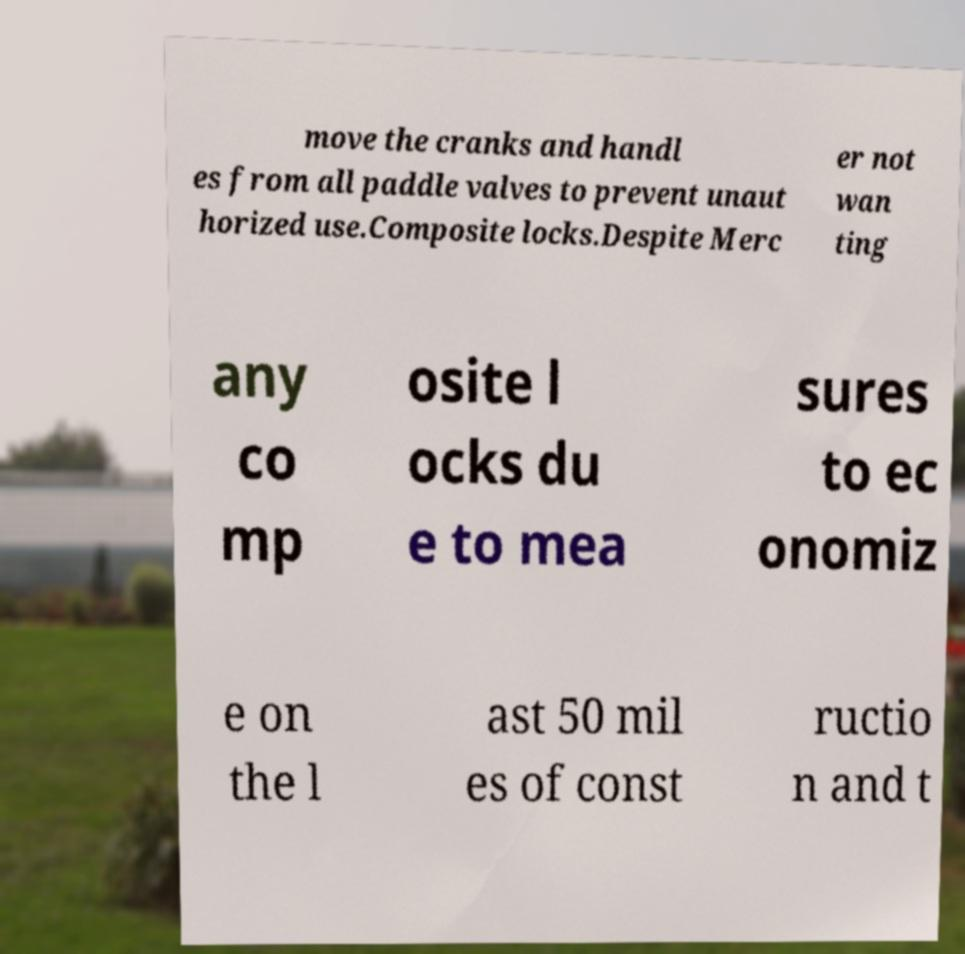There's text embedded in this image that I need extracted. Can you transcribe it verbatim? move the cranks and handl es from all paddle valves to prevent unaut horized use.Composite locks.Despite Merc er not wan ting any co mp osite l ocks du e to mea sures to ec onomiz e on the l ast 50 mil es of const ructio n and t 